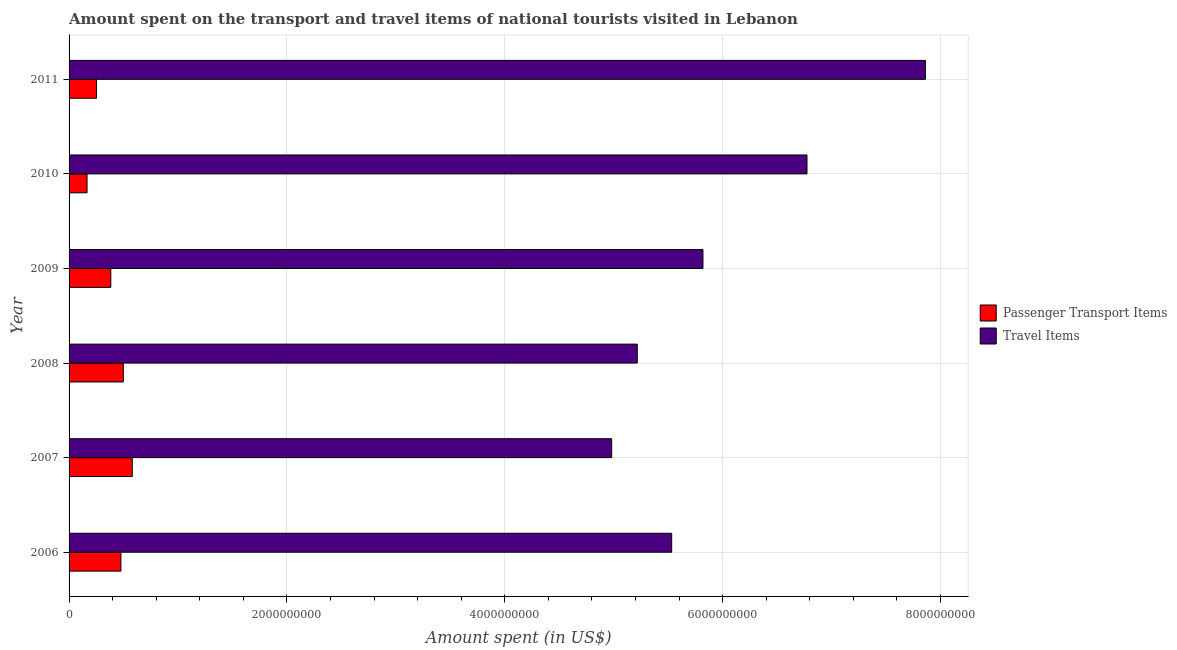How many different coloured bars are there?
Keep it short and to the point. 2. How many groups of bars are there?
Your answer should be compact. 6. Are the number of bars per tick equal to the number of legend labels?
Your answer should be compact. Yes. How many bars are there on the 6th tick from the top?
Offer a very short reply. 2. How many bars are there on the 4th tick from the bottom?
Give a very brief answer. 2. What is the label of the 4th group of bars from the top?
Provide a short and direct response. 2008. In how many cases, is the number of bars for a given year not equal to the number of legend labels?
Give a very brief answer. 0. What is the amount spent in travel items in 2008?
Give a very brief answer. 5.22e+09. Across all years, what is the maximum amount spent in travel items?
Offer a very short reply. 7.86e+09. Across all years, what is the minimum amount spent in travel items?
Keep it short and to the point. 4.98e+09. In which year was the amount spent in travel items maximum?
Offer a terse response. 2011. In which year was the amount spent on passenger transport items minimum?
Your answer should be compact. 2010. What is the total amount spent in travel items in the graph?
Make the answer very short. 3.62e+1. What is the difference between the amount spent in travel items in 2006 and that in 2008?
Your answer should be compact. 3.16e+08. What is the difference between the amount spent on passenger transport items in 2011 and the amount spent in travel items in 2010?
Provide a short and direct response. -6.52e+09. What is the average amount spent on passenger transport items per year?
Provide a short and direct response. 3.92e+08. In the year 2007, what is the difference between the amount spent in travel items and amount spent on passenger transport items?
Provide a succinct answer. 4.40e+09. In how many years, is the amount spent on passenger transport items greater than 1200000000 US$?
Provide a succinct answer. 0. What is the ratio of the amount spent on passenger transport items in 2010 to that in 2011?
Ensure brevity in your answer.  0.66. Is the amount spent in travel items in 2007 less than that in 2010?
Provide a succinct answer. Yes. Is the difference between the amount spent on passenger transport items in 2006 and 2009 greater than the difference between the amount spent in travel items in 2006 and 2009?
Provide a short and direct response. Yes. What is the difference between the highest and the second highest amount spent in travel items?
Your answer should be compact. 1.09e+09. What is the difference between the highest and the lowest amount spent in travel items?
Your answer should be compact. 2.88e+09. In how many years, is the amount spent on passenger transport items greater than the average amount spent on passenger transport items taken over all years?
Give a very brief answer. 3. Is the sum of the amount spent on passenger transport items in 2008 and 2011 greater than the maximum amount spent in travel items across all years?
Provide a short and direct response. No. What does the 2nd bar from the top in 2010 represents?
Your response must be concise. Passenger Transport Items. What does the 2nd bar from the bottom in 2010 represents?
Provide a succinct answer. Travel Items. How many bars are there?
Give a very brief answer. 12. Are the values on the major ticks of X-axis written in scientific E-notation?
Offer a very short reply. No. Does the graph contain any zero values?
Make the answer very short. No. Where does the legend appear in the graph?
Your answer should be very brief. Center right. How many legend labels are there?
Make the answer very short. 2. How are the legend labels stacked?
Your answer should be very brief. Vertical. What is the title of the graph?
Keep it short and to the point. Amount spent on the transport and travel items of national tourists visited in Lebanon. What is the label or title of the X-axis?
Keep it short and to the point. Amount spent (in US$). What is the label or title of the Y-axis?
Your answer should be very brief. Year. What is the Amount spent (in US$) in Passenger Transport Items in 2006?
Provide a succinct answer. 4.76e+08. What is the Amount spent (in US$) in Travel Items in 2006?
Provide a succinct answer. 5.53e+09. What is the Amount spent (in US$) of Passenger Transport Items in 2007?
Provide a short and direct response. 5.80e+08. What is the Amount spent (in US$) of Travel Items in 2007?
Provide a succinct answer. 4.98e+09. What is the Amount spent (in US$) of Passenger Transport Items in 2008?
Your response must be concise. 4.98e+08. What is the Amount spent (in US$) in Travel Items in 2008?
Provide a short and direct response. 5.22e+09. What is the Amount spent (in US$) of Passenger Transport Items in 2009?
Your answer should be very brief. 3.83e+08. What is the Amount spent (in US$) in Travel Items in 2009?
Make the answer very short. 5.82e+09. What is the Amount spent (in US$) of Passenger Transport Items in 2010?
Your answer should be compact. 1.65e+08. What is the Amount spent (in US$) in Travel Items in 2010?
Keep it short and to the point. 6.77e+09. What is the Amount spent (in US$) in Passenger Transport Items in 2011?
Make the answer very short. 2.52e+08. What is the Amount spent (in US$) of Travel Items in 2011?
Make the answer very short. 7.86e+09. Across all years, what is the maximum Amount spent (in US$) in Passenger Transport Items?
Give a very brief answer. 5.80e+08. Across all years, what is the maximum Amount spent (in US$) in Travel Items?
Provide a succinct answer. 7.86e+09. Across all years, what is the minimum Amount spent (in US$) of Passenger Transport Items?
Your answer should be compact. 1.65e+08. Across all years, what is the minimum Amount spent (in US$) of Travel Items?
Offer a terse response. 4.98e+09. What is the total Amount spent (in US$) in Passenger Transport Items in the graph?
Your answer should be very brief. 2.35e+09. What is the total Amount spent (in US$) of Travel Items in the graph?
Offer a very short reply. 3.62e+1. What is the difference between the Amount spent (in US$) of Passenger Transport Items in 2006 and that in 2007?
Keep it short and to the point. -1.04e+08. What is the difference between the Amount spent (in US$) in Travel Items in 2006 and that in 2007?
Provide a short and direct response. 5.51e+08. What is the difference between the Amount spent (in US$) in Passenger Transport Items in 2006 and that in 2008?
Your answer should be very brief. -2.20e+07. What is the difference between the Amount spent (in US$) in Travel Items in 2006 and that in 2008?
Your answer should be very brief. 3.16e+08. What is the difference between the Amount spent (in US$) of Passenger Transport Items in 2006 and that in 2009?
Offer a very short reply. 9.30e+07. What is the difference between the Amount spent (in US$) of Travel Items in 2006 and that in 2009?
Offer a terse response. -2.87e+08. What is the difference between the Amount spent (in US$) of Passenger Transport Items in 2006 and that in 2010?
Give a very brief answer. 3.11e+08. What is the difference between the Amount spent (in US$) in Travel Items in 2006 and that in 2010?
Offer a terse response. -1.24e+09. What is the difference between the Amount spent (in US$) of Passenger Transport Items in 2006 and that in 2011?
Offer a very short reply. 2.24e+08. What is the difference between the Amount spent (in US$) in Travel Items in 2006 and that in 2011?
Offer a terse response. -2.33e+09. What is the difference between the Amount spent (in US$) of Passenger Transport Items in 2007 and that in 2008?
Your answer should be very brief. 8.20e+07. What is the difference between the Amount spent (in US$) of Travel Items in 2007 and that in 2008?
Your answer should be very brief. -2.35e+08. What is the difference between the Amount spent (in US$) in Passenger Transport Items in 2007 and that in 2009?
Provide a succinct answer. 1.97e+08. What is the difference between the Amount spent (in US$) in Travel Items in 2007 and that in 2009?
Provide a short and direct response. -8.38e+08. What is the difference between the Amount spent (in US$) of Passenger Transport Items in 2007 and that in 2010?
Your answer should be compact. 4.15e+08. What is the difference between the Amount spent (in US$) in Travel Items in 2007 and that in 2010?
Ensure brevity in your answer.  -1.79e+09. What is the difference between the Amount spent (in US$) in Passenger Transport Items in 2007 and that in 2011?
Provide a succinct answer. 3.28e+08. What is the difference between the Amount spent (in US$) in Travel Items in 2007 and that in 2011?
Your answer should be very brief. -2.88e+09. What is the difference between the Amount spent (in US$) in Passenger Transport Items in 2008 and that in 2009?
Keep it short and to the point. 1.15e+08. What is the difference between the Amount spent (in US$) in Travel Items in 2008 and that in 2009?
Provide a succinct answer. -6.03e+08. What is the difference between the Amount spent (in US$) in Passenger Transport Items in 2008 and that in 2010?
Your answer should be compact. 3.33e+08. What is the difference between the Amount spent (in US$) in Travel Items in 2008 and that in 2010?
Keep it short and to the point. -1.56e+09. What is the difference between the Amount spent (in US$) of Passenger Transport Items in 2008 and that in 2011?
Offer a terse response. 2.46e+08. What is the difference between the Amount spent (in US$) in Travel Items in 2008 and that in 2011?
Offer a terse response. -2.64e+09. What is the difference between the Amount spent (in US$) of Passenger Transport Items in 2009 and that in 2010?
Keep it short and to the point. 2.18e+08. What is the difference between the Amount spent (in US$) in Travel Items in 2009 and that in 2010?
Your response must be concise. -9.55e+08. What is the difference between the Amount spent (in US$) of Passenger Transport Items in 2009 and that in 2011?
Your answer should be very brief. 1.31e+08. What is the difference between the Amount spent (in US$) of Travel Items in 2009 and that in 2011?
Your answer should be very brief. -2.04e+09. What is the difference between the Amount spent (in US$) in Passenger Transport Items in 2010 and that in 2011?
Your response must be concise. -8.70e+07. What is the difference between the Amount spent (in US$) of Travel Items in 2010 and that in 2011?
Provide a succinct answer. -1.09e+09. What is the difference between the Amount spent (in US$) in Passenger Transport Items in 2006 and the Amount spent (in US$) in Travel Items in 2007?
Give a very brief answer. -4.50e+09. What is the difference between the Amount spent (in US$) of Passenger Transport Items in 2006 and the Amount spent (in US$) of Travel Items in 2008?
Your answer should be very brief. -4.74e+09. What is the difference between the Amount spent (in US$) in Passenger Transport Items in 2006 and the Amount spent (in US$) in Travel Items in 2009?
Give a very brief answer. -5.34e+09. What is the difference between the Amount spent (in US$) in Passenger Transport Items in 2006 and the Amount spent (in US$) in Travel Items in 2010?
Provide a succinct answer. -6.30e+09. What is the difference between the Amount spent (in US$) in Passenger Transport Items in 2006 and the Amount spent (in US$) in Travel Items in 2011?
Give a very brief answer. -7.38e+09. What is the difference between the Amount spent (in US$) of Passenger Transport Items in 2007 and the Amount spent (in US$) of Travel Items in 2008?
Keep it short and to the point. -4.64e+09. What is the difference between the Amount spent (in US$) of Passenger Transport Items in 2007 and the Amount spent (in US$) of Travel Items in 2009?
Give a very brief answer. -5.24e+09. What is the difference between the Amount spent (in US$) in Passenger Transport Items in 2007 and the Amount spent (in US$) in Travel Items in 2010?
Make the answer very short. -6.19e+09. What is the difference between the Amount spent (in US$) of Passenger Transport Items in 2007 and the Amount spent (in US$) of Travel Items in 2011?
Your response must be concise. -7.28e+09. What is the difference between the Amount spent (in US$) in Passenger Transport Items in 2008 and the Amount spent (in US$) in Travel Items in 2009?
Make the answer very short. -5.32e+09. What is the difference between the Amount spent (in US$) of Passenger Transport Items in 2008 and the Amount spent (in US$) of Travel Items in 2010?
Provide a short and direct response. -6.28e+09. What is the difference between the Amount spent (in US$) in Passenger Transport Items in 2008 and the Amount spent (in US$) in Travel Items in 2011?
Give a very brief answer. -7.36e+09. What is the difference between the Amount spent (in US$) in Passenger Transport Items in 2009 and the Amount spent (in US$) in Travel Items in 2010?
Ensure brevity in your answer.  -6.39e+09. What is the difference between the Amount spent (in US$) of Passenger Transport Items in 2009 and the Amount spent (in US$) of Travel Items in 2011?
Make the answer very short. -7.48e+09. What is the difference between the Amount spent (in US$) of Passenger Transport Items in 2010 and the Amount spent (in US$) of Travel Items in 2011?
Make the answer very short. -7.70e+09. What is the average Amount spent (in US$) of Passenger Transport Items per year?
Offer a terse response. 3.92e+08. What is the average Amount spent (in US$) of Travel Items per year?
Your response must be concise. 6.03e+09. In the year 2006, what is the difference between the Amount spent (in US$) in Passenger Transport Items and Amount spent (in US$) in Travel Items?
Keep it short and to the point. -5.06e+09. In the year 2007, what is the difference between the Amount spent (in US$) of Passenger Transport Items and Amount spent (in US$) of Travel Items?
Offer a terse response. -4.40e+09. In the year 2008, what is the difference between the Amount spent (in US$) in Passenger Transport Items and Amount spent (in US$) in Travel Items?
Offer a very short reply. -4.72e+09. In the year 2009, what is the difference between the Amount spent (in US$) in Passenger Transport Items and Amount spent (in US$) in Travel Items?
Offer a very short reply. -5.44e+09. In the year 2010, what is the difference between the Amount spent (in US$) of Passenger Transport Items and Amount spent (in US$) of Travel Items?
Your answer should be compact. -6.61e+09. In the year 2011, what is the difference between the Amount spent (in US$) in Passenger Transport Items and Amount spent (in US$) in Travel Items?
Offer a very short reply. -7.61e+09. What is the ratio of the Amount spent (in US$) of Passenger Transport Items in 2006 to that in 2007?
Your answer should be compact. 0.82. What is the ratio of the Amount spent (in US$) in Travel Items in 2006 to that in 2007?
Offer a very short reply. 1.11. What is the ratio of the Amount spent (in US$) of Passenger Transport Items in 2006 to that in 2008?
Your response must be concise. 0.96. What is the ratio of the Amount spent (in US$) of Travel Items in 2006 to that in 2008?
Your response must be concise. 1.06. What is the ratio of the Amount spent (in US$) in Passenger Transport Items in 2006 to that in 2009?
Your response must be concise. 1.24. What is the ratio of the Amount spent (in US$) of Travel Items in 2006 to that in 2009?
Provide a short and direct response. 0.95. What is the ratio of the Amount spent (in US$) in Passenger Transport Items in 2006 to that in 2010?
Your answer should be compact. 2.88. What is the ratio of the Amount spent (in US$) in Travel Items in 2006 to that in 2010?
Provide a succinct answer. 0.82. What is the ratio of the Amount spent (in US$) in Passenger Transport Items in 2006 to that in 2011?
Offer a very short reply. 1.89. What is the ratio of the Amount spent (in US$) of Travel Items in 2006 to that in 2011?
Your answer should be very brief. 0.7. What is the ratio of the Amount spent (in US$) of Passenger Transport Items in 2007 to that in 2008?
Offer a terse response. 1.16. What is the ratio of the Amount spent (in US$) in Travel Items in 2007 to that in 2008?
Keep it short and to the point. 0.95. What is the ratio of the Amount spent (in US$) of Passenger Transport Items in 2007 to that in 2009?
Offer a terse response. 1.51. What is the ratio of the Amount spent (in US$) of Travel Items in 2007 to that in 2009?
Your answer should be very brief. 0.86. What is the ratio of the Amount spent (in US$) in Passenger Transport Items in 2007 to that in 2010?
Offer a terse response. 3.52. What is the ratio of the Amount spent (in US$) in Travel Items in 2007 to that in 2010?
Provide a short and direct response. 0.74. What is the ratio of the Amount spent (in US$) of Passenger Transport Items in 2007 to that in 2011?
Offer a very short reply. 2.3. What is the ratio of the Amount spent (in US$) in Travel Items in 2007 to that in 2011?
Offer a very short reply. 0.63. What is the ratio of the Amount spent (in US$) in Passenger Transport Items in 2008 to that in 2009?
Ensure brevity in your answer.  1.3. What is the ratio of the Amount spent (in US$) in Travel Items in 2008 to that in 2009?
Keep it short and to the point. 0.9. What is the ratio of the Amount spent (in US$) in Passenger Transport Items in 2008 to that in 2010?
Offer a very short reply. 3.02. What is the ratio of the Amount spent (in US$) in Travel Items in 2008 to that in 2010?
Provide a short and direct response. 0.77. What is the ratio of the Amount spent (in US$) in Passenger Transport Items in 2008 to that in 2011?
Provide a short and direct response. 1.98. What is the ratio of the Amount spent (in US$) in Travel Items in 2008 to that in 2011?
Your response must be concise. 0.66. What is the ratio of the Amount spent (in US$) in Passenger Transport Items in 2009 to that in 2010?
Offer a terse response. 2.32. What is the ratio of the Amount spent (in US$) of Travel Items in 2009 to that in 2010?
Provide a short and direct response. 0.86. What is the ratio of the Amount spent (in US$) of Passenger Transport Items in 2009 to that in 2011?
Provide a succinct answer. 1.52. What is the ratio of the Amount spent (in US$) of Travel Items in 2009 to that in 2011?
Provide a succinct answer. 0.74. What is the ratio of the Amount spent (in US$) of Passenger Transport Items in 2010 to that in 2011?
Your answer should be very brief. 0.65. What is the ratio of the Amount spent (in US$) in Travel Items in 2010 to that in 2011?
Ensure brevity in your answer.  0.86. What is the difference between the highest and the second highest Amount spent (in US$) in Passenger Transport Items?
Make the answer very short. 8.20e+07. What is the difference between the highest and the second highest Amount spent (in US$) in Travel Items?
Your response must be concise. 1.09e+09. What is the difference between the highest and the lowest Amount spent (in US$) of Passenger Transport Items?
Ensure brevity in your answer.  4.15e+08. What is the difference between the highest and the lowest Amount spent (in US$) of Travel Items?
Offer a terse response. 2.88e+09. 